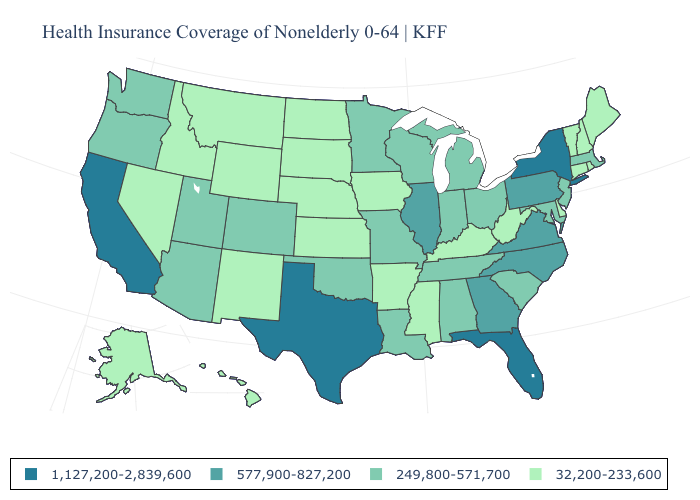How many symbols are there in the legend?
Quick response, please. 4. What is the value of Georgia?
Give a very brief answer. 577,900-827,200. Name the states that have a value in the range 1,127,200-2,839,600?
Keep it brief. California, Florida, New York, Texas. Name the states that have a value in the range 1,127,200-2,839,600?
Short answer required. California, Florida, New York, Texas. What is the highest value in the USA?
Keep it brief. 1,127,200-2,839,600. How many symbols are there in the legend?
Short answer required. 4. Name the states that have a value in the range 1,127,200-2,839,600?
Answer briefly. California, Florida, New York, Texas. What is the value of Louisiana?
Answer briefly. 249,800-571,700. What is the lowest value in states that border Florida?
Be succinct. 249,800-571,700. Among the states that border Florida , which have the lowest value?
Give a very brief answer. Alabama. Name the states that have a value in the range 249,800-571,700?
Be succinct. Alabama, Arizona, Colorado, Indiana, Louisiana, Maryland, Massachusetts, Michigan, Minnesota, Missouri, New Jersey, Ohio, Oklahoma, Oregon, South Carolina, Tennessee, Utah, Washington, Wisconsin. Name the states that have a value in the range 577,900-827,200?
Write a very short answer. Georgia, Illinois, North Carolina, Pennsylvania, Virginia. What is the value of Wyoming?
Answer briefly. 32,200-233,600. What is the value of Pennsylvania?
Concise answer only. 577,900-827,200. 